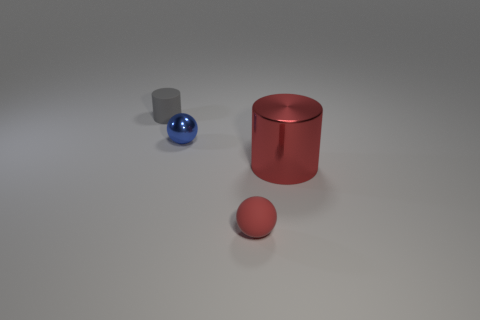Add 1 small green shiny balls. How many objects exist? 5 Add 1 tiny matte objects. How many tiny matte objects are left? 3 Add 3 big yellow metallic spheres. How many big yellow metallic spheres exist? 3 Subtract 0 yellow blocks. How many objects are left? 4 Subtract all big blue metal blocks. Subtract all red metal things. How many objects are left? 3 